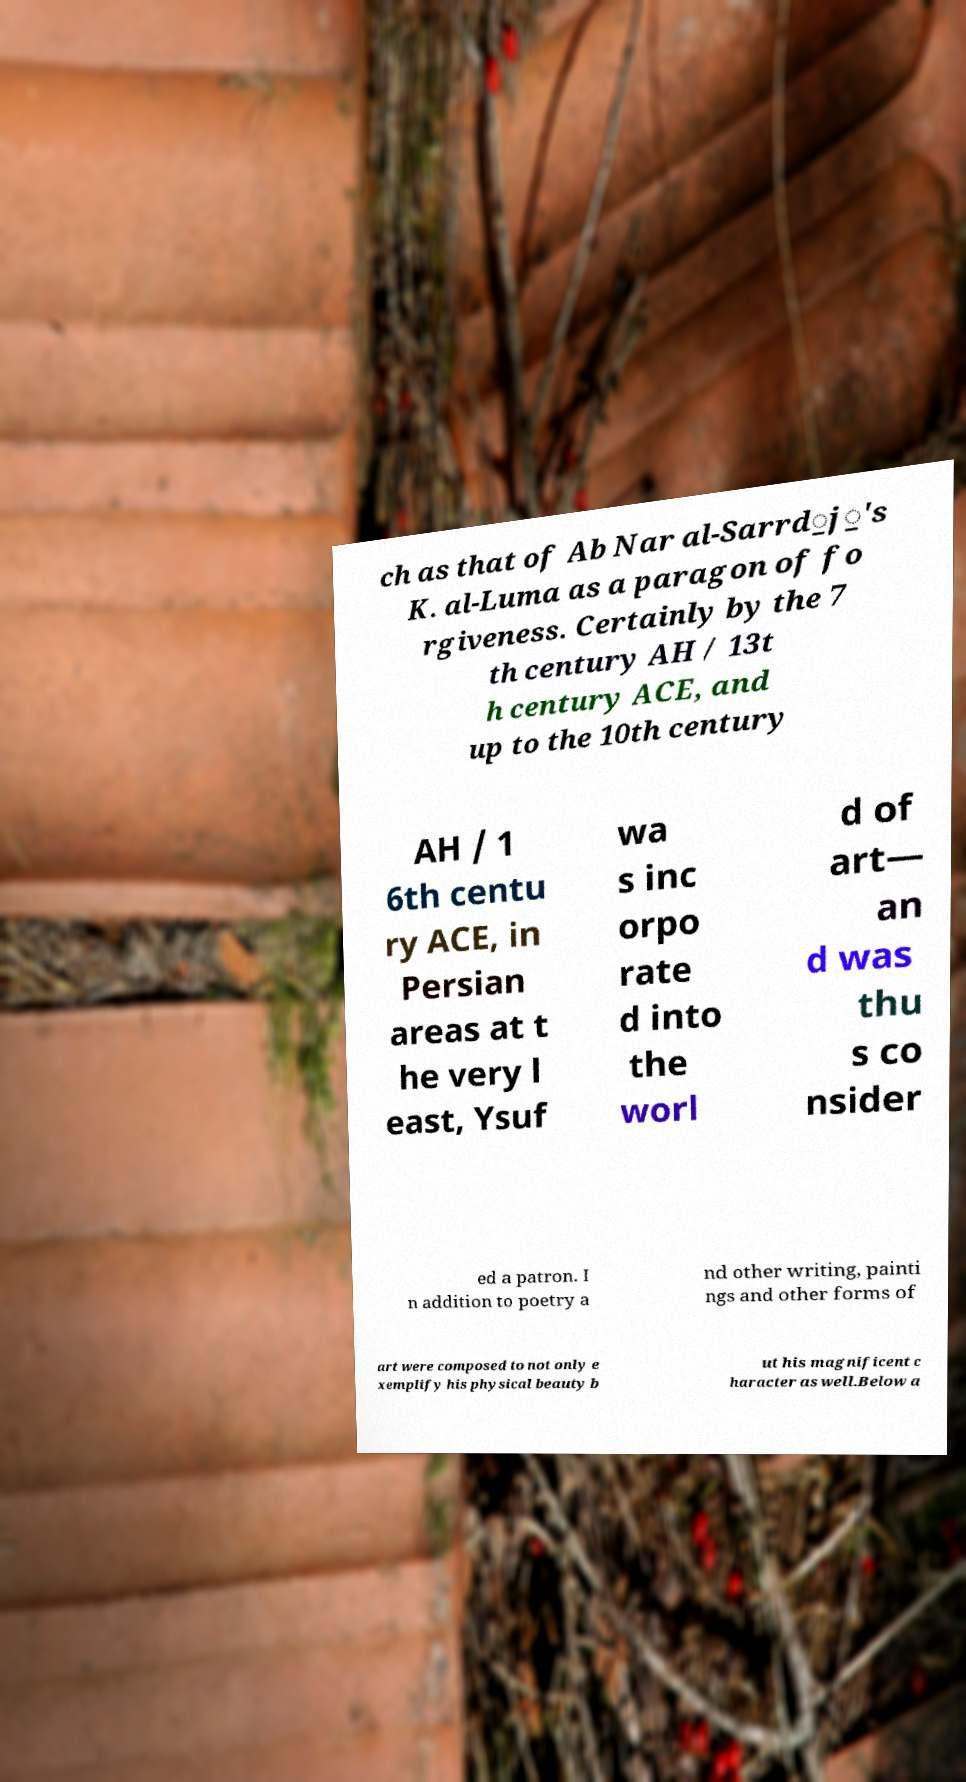There's text embedded in this image that I need extracted. Can you transcribe it verbatim? ch as that of Ab Nar al-Sarrd̲j̲'s K. al-Luma as a paragon of fo rgiveness. Certainly by the 7 th century AH / 13t h century ACE, and up to the 10th century AH / 1 6th centu ry ACE, in Persian areas at t he very l east, Ysuf wa s inc orpo rate d into the worl d of art— an d was thu s co nsider ed a patron. I n addition to poetry a nd other writing, painti ngs and other forms of art were composed to not only e xemplify his physical beauty b ut his magnificent c haracter as well.Below a 